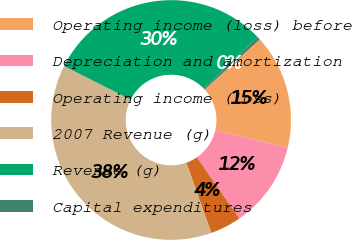<chart> <loc_0><loc_0><loc_500><loc_500><pie_chart><fcel>Operating income (loss) before<fcel>Depreciation and amortization<fcel>Operating income (loss)<fcel>2007 Revenue (g)<fcel>Revenue (g)<fcel>Capital expenditures<nl><fcel>15.42%<fcel>11.68%<fcel>4.2%<fcel>37.86%<fcel>30.37%<fcel>0.46%<nl></chart> 